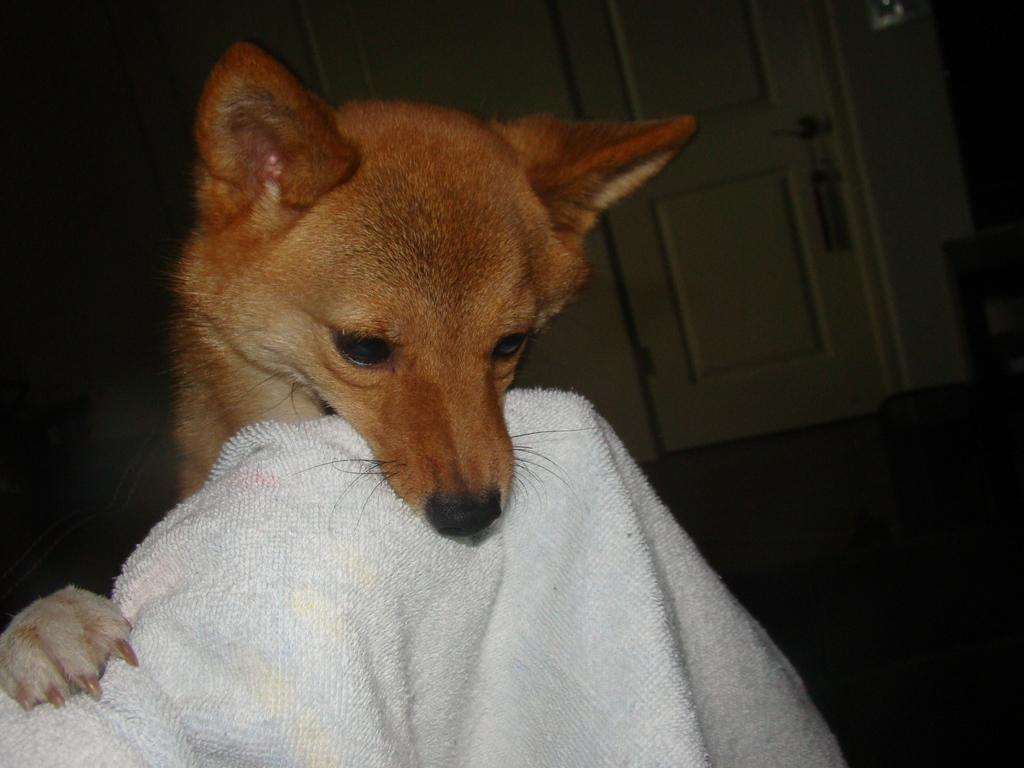What type of animal is in the image? There is a dog in the image. What is the dog doing in the image? The dog is holding a cloth in its mouth. What type of surface is visible in the image? The image shows a floor. What can be seen in the background of the image? There is a door and a wall in the background of the image. Is the dog a beginner at using a gun in the image? There is no gun present in the image, and the dog is not performing any action related to using a gun. 